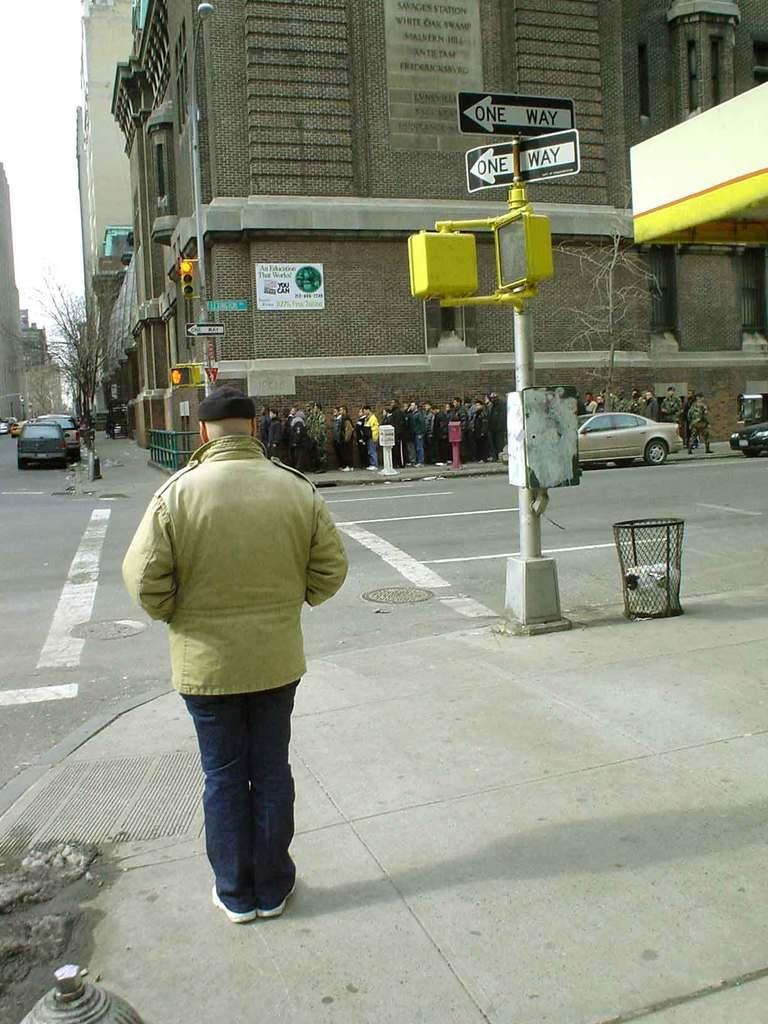Describe this image in one or two sentences. In this image we can see persons standing on the road, buildings, traffic poles, traffic signals, motor vehicles on the road, trash bins, sign boards, trees and sky. 